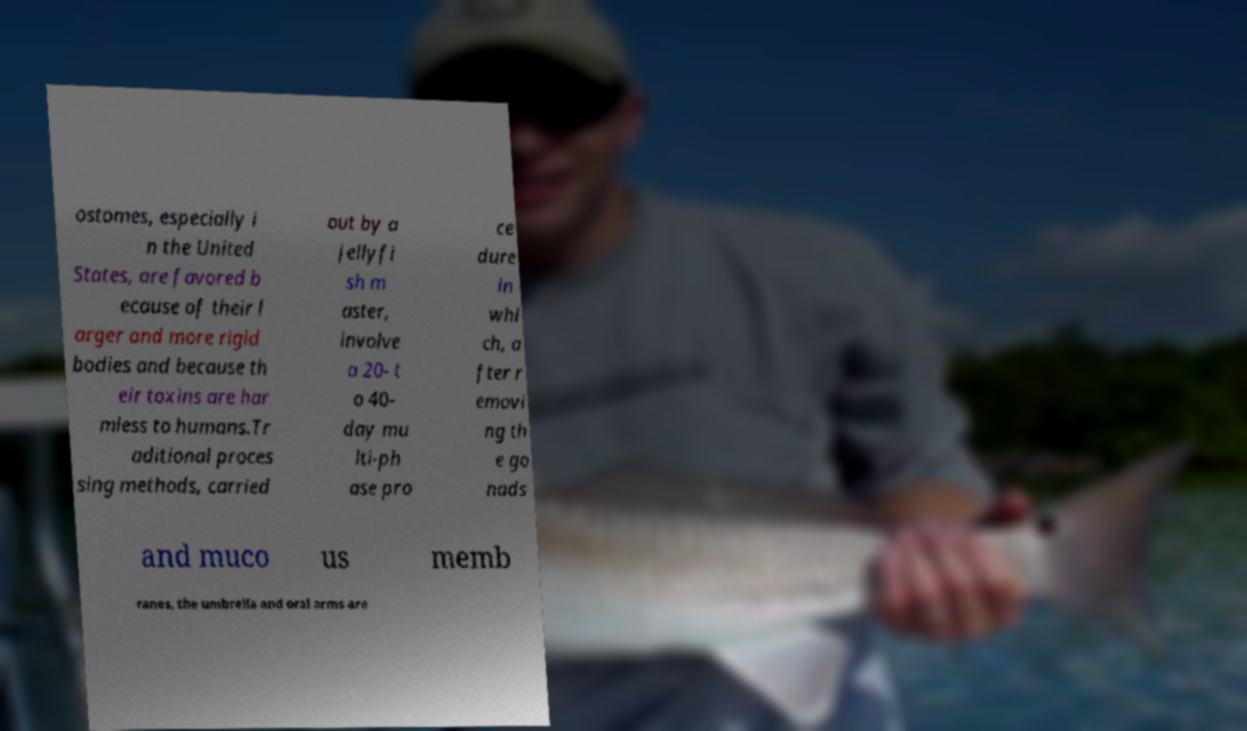Could you extract and type out the text from this image? ostomes, especially i n the United States, are favored b ecause of their l arger and more rigid bodies and because th eir toxins are har mless to humans.Tr aditional proces sing methods, carried out by a jellyfi sh m aster, involve a 20- t o 40- day mu lti-ph ase pro ce dure in whi ch, a fter r emovi ng th e go nads and muco us memb ranes, the umbrella and oral arms are 